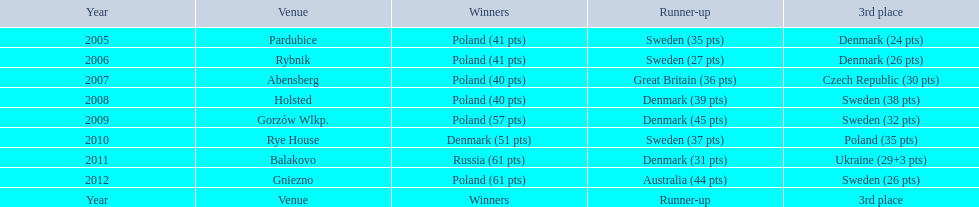What is the latest year in which the competitor finishing in 3rd place had under 25 points? 2005. 